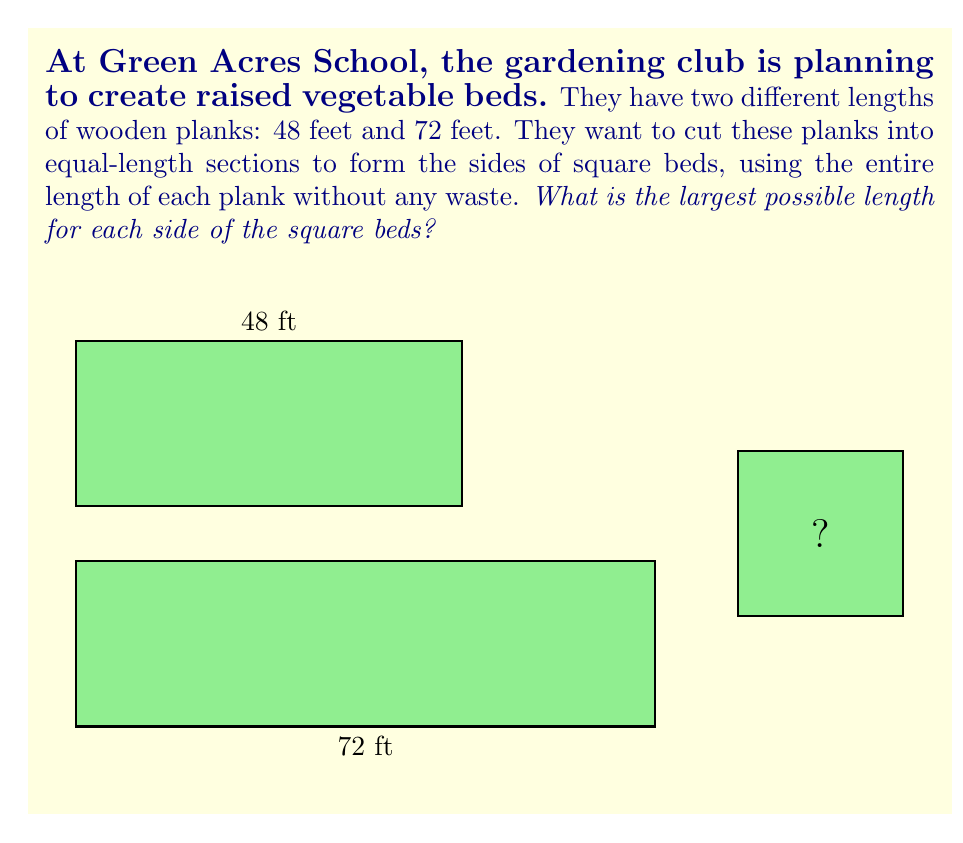Help me with this question. To solve this problem, we need to find the greatest common divisor (GCD) of 48 and 72. The GCD will give us the largest possible length for each side of the square beds that evenly divides both plank lengths.

Let's use the Euclidean algorithm to find the GCD:

1) First, divide 72 by 48:
   $72 = 1 \times 48 + 24$

2) Now divide 48 by 24:
   $48 = 2 \times 24 + 0$

3) Since the remainder is 0, the GCD is 24.

We can verify this:
$48 \div 24 = 2$ (exactly)
$72 \div 24 = 3$ (exactly)

Therefore, the largest possible length for each side of the square beds is 24 feet.

This means:
- The 48-foot plank can make 2 sides
- The 72-foot plank can make 3 sides

Together, they can create 5 sides, which is enough for one complete square bed with one extra side.
Answer: 24 feet 